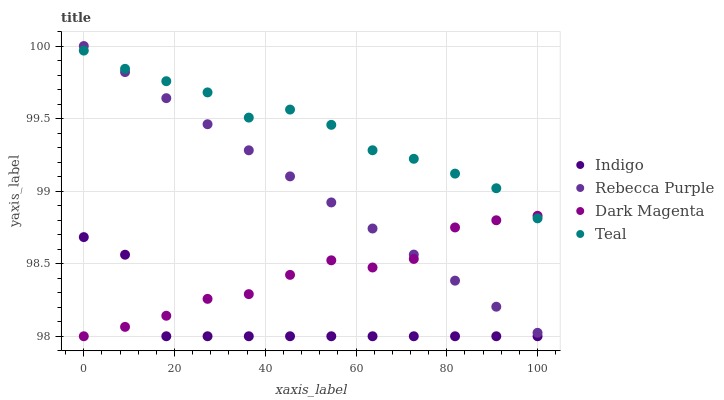Does Indigo have the minimum area under the curve?
Answer yes or no. Yes. Does Teal have the maximum area under the curve?
Answer yes or no. Yes. Does Rebecca Purple have the minimum area under the curve?
Answer yes or no. No. Does Rebecca Purple have the maximum area under the curve?
Answer yes or no. No. Is Rebecca Purple the smoothest?
Answer yes or no. Yes. Is Indigo the roughest?
Answer yes or no. Yes. Is Teal the smoothest?
Answer yes or no. No. Is Teal the roughest?
Answer yes or no. No. Does Indigo have the lowest value?
Answer yes or no. Yes. Does Rebecca Purple have the lowest value?
Answer yes or no. No. Does Rebecca Purple have the highest value?
Answer yes or no. Yes. Does Teal have the highest value?
Answer yes or no. No. Is Indigo less than Teal?
Answer yes or no. Yes. Is Rebecca Purple greater than Indigo?
Answer yes or no. Yes. Does Rebecca Purple intersect Teal?
Answer yes or no. Yes. Is Rebecca Purple less than Teal?
Answer yes or no. No. Is Rebecca Purple greater than Teal?
Answer yes or no. No. Does Indigo intersect Teal?
Answer yes or no. No. 